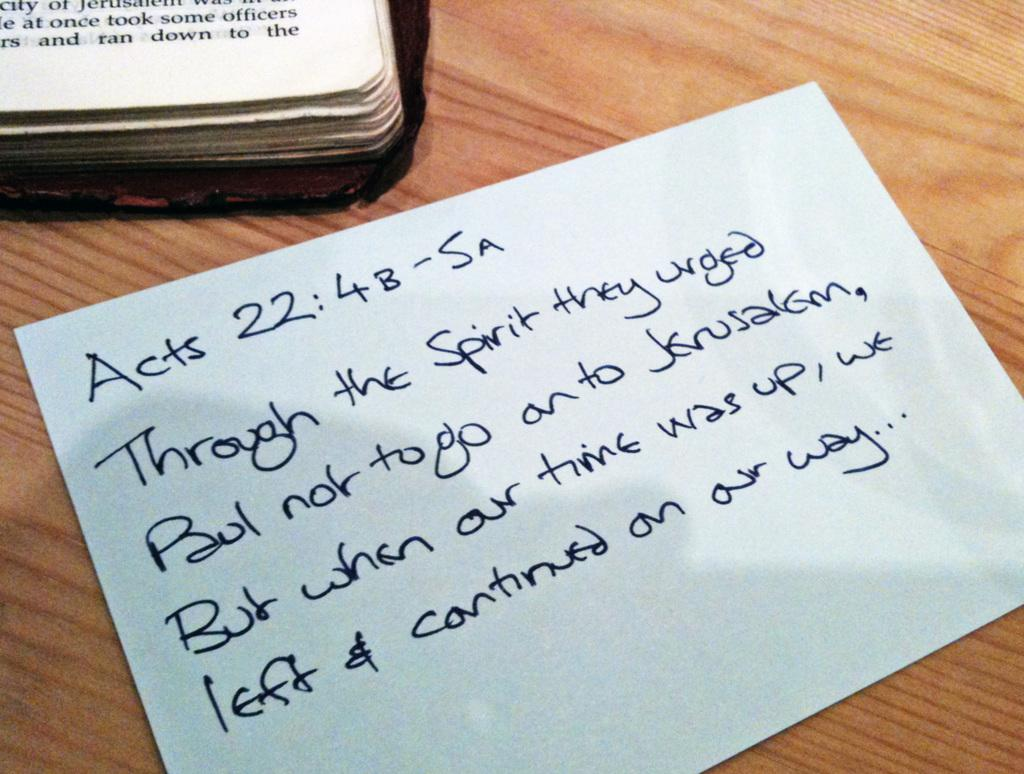<image>
Provide a brief description of the given image. a note starting with the words Acts 22:4 